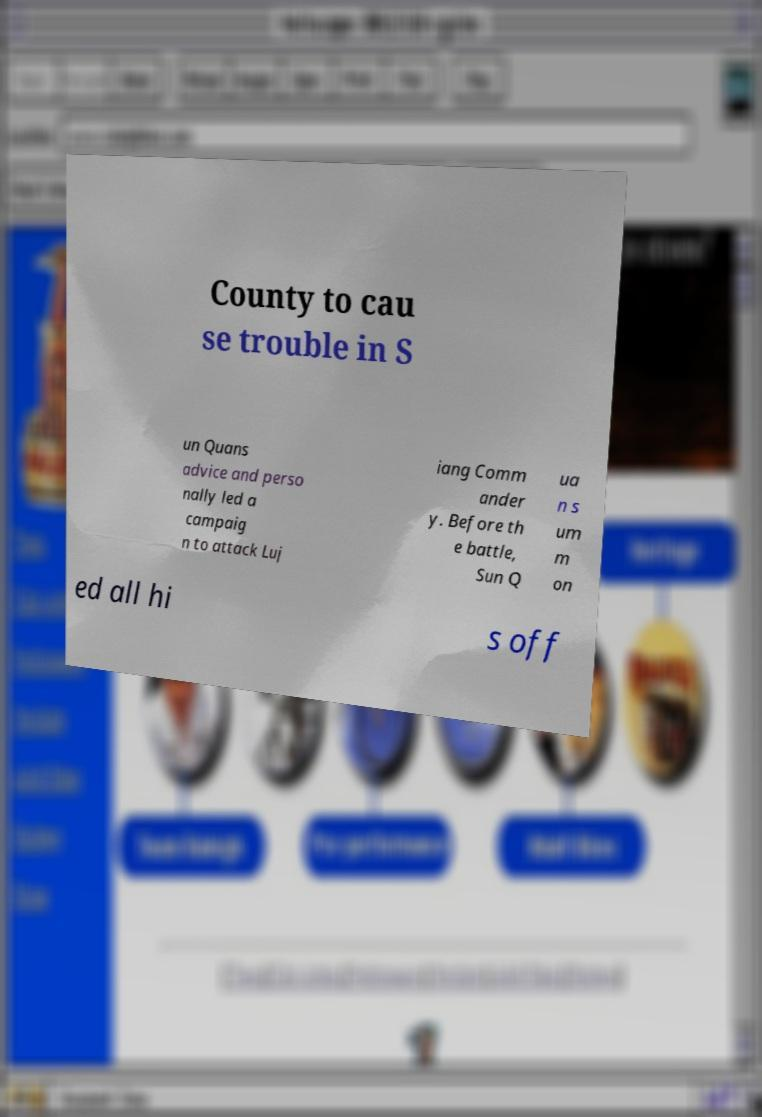What messages or text are displayed in this image? I need them in a readable, typed format. County to cau se trouble in S un Quans advice and perso nally led a campaig n to attack Luj iang Comm ander y. Before th e battle, Sun Q ua n s um m on ed all hi s off 